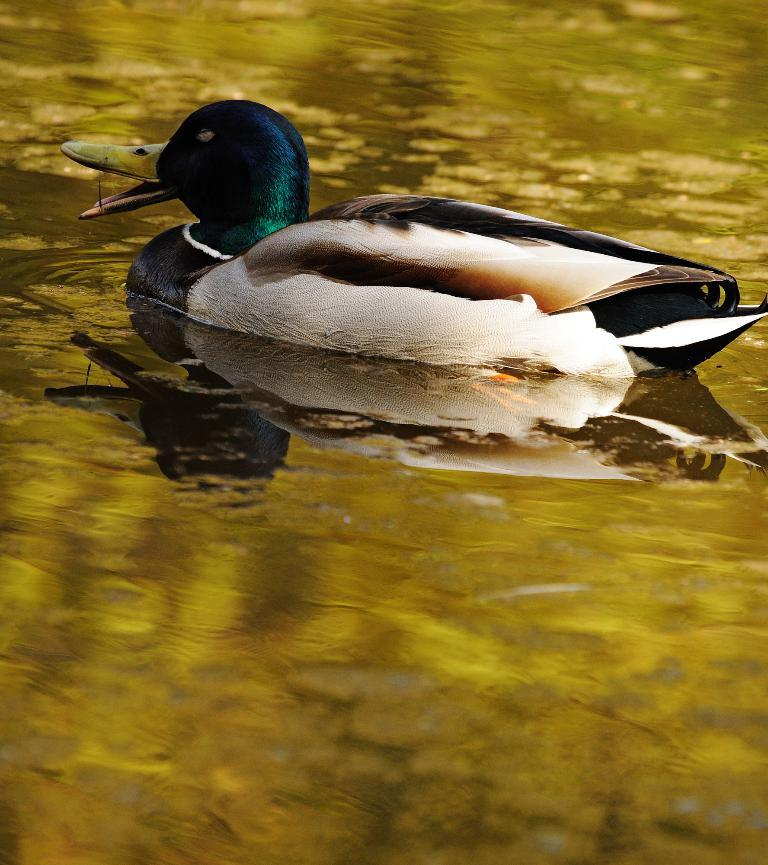What type of animal is in the image? There is a duck in the image. Where is the duck located in the image? The duck is in the water. What color is the vein of the duck in the image? There is no visible vein on the duck in the image, and therefore no such color can be determined. What type of ink is used to draw the duck in the image? The image is a photograph, not a drawing, so there is no ink used in the image. 